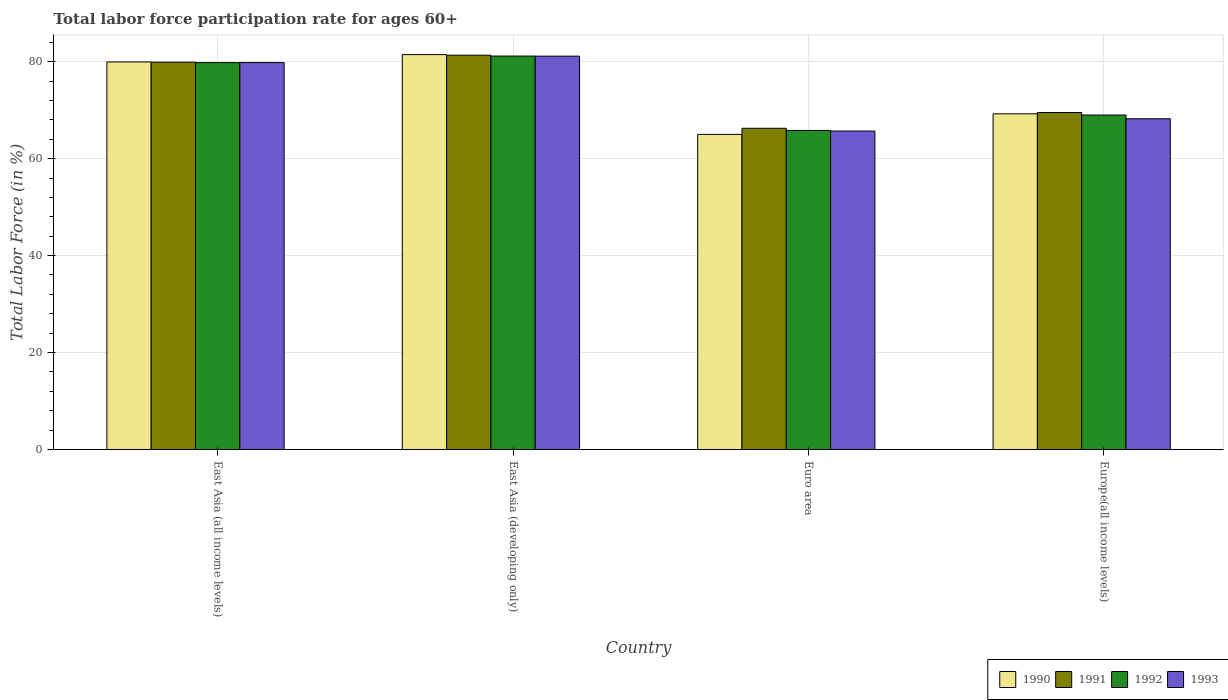How many different coloured bars are there?
Provide a succinct answer. 4. How many groups of bars are there?
Your answer should be very brief. 4. Are the number of bars per tick equal to the number of legend labels?
Your answer should be compact. Yes. Are the number of bars on each tick of the X-axis equal?
Ensure brevity in your answer.  Yes. How many bars are there on the 3rd tick from the left?
Give a very brief answer. 4. How many bars are there on the 4th tick from the right?
Offer a very short reply. 4. What is the label of the 2nd group of bars from the left?
Offer a very short reply. East Asia (developing only). What is the labor force participation rate in 1991 in East Asia (all income levels)?
Your response must be concise. 79.9. Across all countries, what is the maximum labor force participation rate in 1991?
Offer a terse response. 81.33. Across all countries, what is the minimum labor force participation rate in 1993?
Offer a terse response. 65.69. In which country was the labor force participation rate in 1991 maximum?
Keep it short and to the point. East Asia (developing only). In which country was the labor force participation rate in 1991 minimum?
Ensure brevity in your answer.  Euro area. What is the total labor force participation rate in 1990 in the graph?
Your response must be concise. 295.64. What is the difference between the labor force participation rate in 1990 in East Asia (developing only) and that in Europe(all income levels)?
Give a very brief answer. 12.21. What is the difference between the labor force participation rate in 1991 in Euro area and the labor force participation rate in 1990 in Europe(all income levels)?
Provide a short and direct response. -2.99. What is the average labor force participation rate in 1993 per country?
Offer a very short reply. 73.71. What is the difference between the labor force participation rate of/in 1991 and labor force participation rate of/in 1993 in Europe(all income levels)?
Give a very brief answer. 1.29. What is the ratio of the labor force participation rate in 1992 in East Asia (all income levels) to that in Euro area?
Provide a short and direct response. 1.21. What is the difference between the highest and the second highest labor force participation rate in 1990?
Your answer should be compact. 12.21. What is the difference between the highest and the lowest labor force participation rate in 1993?
Ensure brevity in your answer.  15.45. Is the sum of the labor force participation rate in 1990 in East Asia (developing only) and Euro area greater than the maximum labor force participation rate in 1992 across all countries?
Ensure brevity in your answer.  Yes. What does the 2nd bar from the left in Europe(all income levels) represents?
Offer a very short reply. 1991. Are all the bars in the graph horizontal?
Provide a succinct answer. No. How many countries are there in the graph?
Your answer should be compact. 4. What is the difference between two consecutive major ticks on the Y-axis?
Your answer should be very brief. 20. Are the values on the major ticks of Y-axis written in scientific E-notation?
Give a very brief answer. No. Where does the legend appear in the graph?
Give a very brief answer. Bottom right. How many legend labels are there?
Give a very brief answer. 4. What is the title of the graph?
Provide a succinct answer. Total labor force participation rate for ages 60+. Does "1991" appear as one of the legend labels in the graph?
Give a very brief answer. Yes. What is the label or title of the Y-axis?
Give a very brief answer. Total Labor Force (in %). What is the Total Labor Force (in %) in 1990 in East Asia (all income levels)?
Provide a succinct answer. 79.95. What is the Total Labor Force (in %) of 1991 in East Asia (all income levels)?
Your response must be concise. 79.9. What is the Total Labor Force (in %) in 1992 in East Asia (all income levels)?
Give a very brief answer. 79.8. What is the Total Labor Force (in %) of 1993 in East Asia (all income levels)?
Offer a terse response. 79.81. What is the Total Labor Force (in %) of 1990 in East Asia (developing only)?
Ensure brevity in your answer.  81.45. What is the Total Labor Force (in %) of 1991 in East Asia (developing only)?
Your answer should be compact. 81.33. What is the Total Labor Force (in %) of 1992 in East Asia (developing only)?
Your answer should be very brief. 81.16. What is the Total Labor Force (in %) of 1993 in East Asia (developing only)?
Ensure brevity in your answer.  81.14. What is the Total Labor Force (in %) of 1990 in Euro area?
Give a very brief answer. 65. What is the Total Labor Force (in %) of 1991 in Euro area?
Make the answer very short. 66.26. What is the Total Labor Force (in %) in 1992 in Euro area?
Provide a succinct answer. 65.81. What is the Total Labor Force (in %) in 1993 in Euro area?
Give a very brief answer. 65.69. What is the Total Labor Force (in %) in 1990 in Europe(all income levels)?
Your answer should be very brief. 69.24. What is the Total Labor Force (in %) in 1991 in Europe(all income levels)?
Your answer should be compact. 69.51. What is the Total Labor Force (in %) of 1992 in Europe(all income levels)?
Offer a very short reply. 68.99. What is the Total Labor Force (in %) in 1993 in Europe(all income levels)?
Give a very brief answer. 68.22. Across all countries, what is the maximum Total Labor Force (in %) of 1990?
Offer a terse response. 81.45. Across all countries, what is the maximum Total Labor Force (in %) of 1991?
Provide a succinct answer. 81.33. Across all countries, what is the maximum Total Labor Force (in %) of 1992?
Offer a very short reply. 81.16. Across all countries, what is the maximum Total Labor Force (in %) in 1993?
Offer a terse response. 81.14. Across all countries, what is the minimum Total Labor Force (in %) in 1990?
Your answer should be very brief. 65. Across all countries, what is the minimum Total Labor Force (in %) of 1991?
Provide a short and direct response. 66.26. Across all countries, what is the minimum Total Labor Force (in %) in 1992?
Your response must be concise. 65.81. Across all countries, what is the minimum Total Labor Force (in %) in 1993?
Ensure brevity in your answer.  65.69. What is the total Total Labor Force (in %) in 1990 in the graph?
Give a very brief answer. 295.64. What is the total Total Labor Force (in %) in 1991 in the graph?
Your response must be concise. 297. What is the total Total Labor Force (in %) in 1992 in the graph?
Ensure brevity in your answer.  295.76. What is the total Total Labor Force (in %) of 1993 in the graph?
Your answer should be compact. 294.86. What is the difference between the Total Labor Force (in %) of 1990 in East Asia (all income levels) and that in East Asia (developing only)?
Offer a terse response. -1.51. What is the difference between the Total Labor Force (in %) in 1991 in East Asia (all income levels) and that in East Asia (developing only)?
Provide a short and direct response. -1.43. What is the difference between the Total Labor Force (in %) of 1992 in East Asia (all income levels) and that in East Asia (developing only)?
Make the answer very short. -1.36. What is the difference between the Total Labor Force (in %) in 1993 in East Asia (all income levels) and that in East Asia (developing only)?
Provide a short and direct response. -1.33. What is the difference between the Total Labor Force (in %) in 1990 in East Asia (all income levels) and that in Euro area?
Give a very brief answer. 14.95. What is the difference between the Total Labor Force (in %) in 1991 in East Asia (all income levels) and that in Euro area?
Offer a very short reply. 13.64. What is the difference between the Total Labor Force (in %) in 1992 in East Asia (all income levels) and that in Euro area?
Give a very brief answer. 13.99. What is the difference between the Total Labor Force (in %) in 1993 in East Asia (all income levels) and that in Euro area?
Give a very brief answer. 14.12. What is the difference between the Total Labor Force (in %) in 1990 in East Asia (all income levels) and that in Europe(all income levels)?
Ensure brevity in your answer.  10.7. What is the difference between the Total Labor Force (in %) in 1991 in East Asia (all income levels) and that in Europe(all income levels)?
Ensure brevity in your answer.  10.39. What is the difference between the Total Labor Force (in %) in 1992 in East Asia (all income levels) and that in Europe(all income levels)?
Provide a succinct answer. 10.81. What is the difference between the Total Labor Force (in %) in 1993 in East Asia (all income levels) and that in Europe(all income levels)?
Make the answer very short. 11.59. What is the difference between the Total Labor Force (in %) in 1990 in East Asia (developing only) and that in Euro area?
Give a very brief answer. 16.45. What is the difference between the Total Labor Force (in %) in 1991 in East Asia (developing only) and that in Euro area?
Ensure brevity in your answer.  15.07. What is the difference between the Total Labor Force (in %) in 1992 in East Asia (developing only) and that in Euro area?
Keep it short and to the point. 15.34. What is the difference between the Total Labor Force (in %) in 1993 in East Asia (developing only) and that in Euro area?
Make the answer very short. 15.45. What is the difference between the Total Labor Force (in %) of 1990 in East Asia (developing only) and that in Europe(all income levels)?
Your answer should be compact. 12.21. What is the difference between the Total Labor Force (in %) of 1991 in East Asia (developing only) and that in Europe(all income levels)?
Offer a very short reply. 11.82. What is the difference between the Total Labor Force (in %) in 1992 in East Asia (developing only) and that in Europe(all income levels)?
Your response must be concise. 12.17. What is the difference between the Total Labor Force (in %) of 1993 in East Asia (developing only) and that in Europe(all income levels)?
Provide a short and direct response. 12.91. What is the difference between the Total Labor Force (in %) in 1990 in Euro area and that in Europe(all income levels)?
Your response must be concise. -4.24. What is the difference between the Total Labor Force (in %) of 1991 in Euro area and that in Europe(all income levels)?
Provide a succinct answer. -3.25. What is the difference between the Total Labor Force (in %) of 1992 in Euro area and that in Europe(all income levels)?
Offer a terse response. -3.18. What is the difference between the Total Labor Force (in %) of 1993 in Euro area and that in Europe(all income levels)?
Provide a short and direct response. -2.54. What is the difference between the Total Labor Force (in %) of 1990 in East Asia (all income levels) and the Total Labor Force (in %) of 1991 in East Asia (developing only)?
Your answer should be very brief. -1.39. What is the difference between the Total Labor Force (in %) in 1990 in East Asia (all income levels) and the Total Labor Force (in %) in 1992 in East Asia (developing only)?
Make the answer very short. -1.21. What is the difference between the Total Labor Force (in %) in 1990 in East Asia (all income levels) and the Total Labor Force (in %) in 1993 in East Asia (developing only)?
Your answer should be compact. -1.19. What is the difference between the Total Labor Force (in %) in 1991 in East Asia (all income levels) and the Total Labor Force (in %) in 1992 in East Asia (developing only)?
Make the answer very short. -1.26. What is the difference between the Total Labor Force (in %) in 1991 in East Asia (all income levels) and the Total Labor Force (in %) in 1993 in East Asia (developing only)?
Offer a very short reply. -1.24. What is the difference between the Total Labor Force (in %) of 1992 in East Asia (all income levels) and the Total Labor Force (in %) of 1993 in East Asia (developing only)?
Your answer should be very brief. -1.34. What is the difference between the Total Labor Force (in %) of 1990 in East Asia (all income levels) and the Total Labor Force (in %) of 1991 in Euro area?
Ensure brevity in your answer.  13.69. What is the difference between the Total Labor Force (in %) of 1990 in East Asia (all income levels) and the Total Labor Force (in %) of 1992 in Euro area?
Provide a short and direct response. 14.13. What is the difference between the Total Labor Force (in %) of 1990 in East Asia (all income levels) and the Total Labor Force (in %) of 1993 in Euro area?
Your answer should be compact. 14.26. What is the difference between the Total Labor Force (in %) of 1991 in East Asia (all income levels) and the Total Labor Force (in %) of 1992 in Euro area?
Your response must be concise. 14.09. What is the difference between the Total Labor Force (in %) in 1991 in East Asia (all income levels) and the Total Labor Force (in %) in 1993 in Euro area?
Offer a terse response. 14.22. What is the difference between the Total Labor Force (in %) of 1992 in East Asia (all income levels) and the Total Labor Force (in %) of 1993 in Euro area?
Ensure brevity in your answer.  14.12. What is the difference between the Total Labor Force (in %) in 1990 in East Asia (all income levels) and the Total Labor Force (in %) in 1991 in Europe(all income levels)?
Provide a short and direct response. 10.43. What is the difference between the Total Labor Force (in %) in 1990 in East Asia (all income levels) and the Total Labor Force (in %) in 1992 in Europe(all income levels)?
Your answer should be very brief. 10.95. What is the difference between the Total Labor Force (in %) of 1990 in East Asia (all income levels) and the Total Labor Force (in %) of 1993 in Europe(all income levels)?
Offer a terse response. 11.72. What is the difference between the Total Labor Force (in %) in 1991 in East Asia (all income levels) and the Total Labor Force (in %) in 1992 in Europe(all income levels)?
Give a very brief answer. 10.91. What is the difference between the Total Labor Force (in %) in 1991 in East Asia (all income levels) and the Total Labor Force (in %) in 1993 in Europe(all income levels)?
Keep it short and to the point. 11.68. What is the difference between the Total Labor Force (in %) of 1992 in East Asia (all income levels) and the Total Labor Force (in %) of 1993 in Europe(all income levels)?
Your answer should be very brief. 11.58. What is the difference between the Total Labor Force (in %) of 1990 in East Asia (developing only) and the Total Labor Force (in %) of 1991 in Euro area?
Your response must be concise. 15.19. What is the difference between the Total Labor Force (in %) in 1990 in East Asia (developing only) and the Total Labor Force (in %) in 1992 in Euro area?
Give a very brief answer. 15.64. What is the difference between the Total Labor Force (in %) of 1990 in East Asia (developing only) and the Total Labor Force (in %) of 1993 in Euro area?
Provide a succinct answer. 15.77. What is the difference between the Total Labor Force (in %) in 1991 in East Asia (developing only) and the Total Labor Force (in %) in 1992 in Euro area?
Make the answer very short. 15.52. What is the difference between the Total Labor Force (in %) of 1991 in East Asia (developing only) and the Total Labor Force (in %) of 1993 in Euro area?
Your answer should be very brief. 15.65. What is the difference between the Total Labor Force (in %) in 1992 in East Asia (developing only) and the Total Labor Force (in %) in 1993 in Euro area?
Your answer should be very brief. 15.47. What is the difference between the Total Labor Force (in %) in 1990 in East Asia (developing only) and the Total Labor Force (in %) in 1991 in Europe(all income levels)?
Give a very brief answer. 11.94. What is the difference between the Total Labor Force (in %) in 1990 in East Asia (developing only) and the Total Labor Force (in %) in 1992 in Europe(all income levels)?
Keep it short and to the point. 12.46. What is the difference between the Total Labor Force (in %) of 1990 in East Asia (developing only) and the Total Labor Force (in %) of 1993 in Europe(all income levels)?
Keep it short and to the point. 13.23. What is the difference between the Total Labor Force (in %) in 1991 in East Asia (developing only) and the Total Labor Force (in %) in 1992 in Europe(all income levels)?
Your response must be concise. 12.34. What is the difference between the Total Labor Force (in %) of 1991 in East Asia (developing only) and the Total Labor Force (in %) of 1993 in Europe(all income levels)?
Give a very brief answer. 13.11. What is the difference between the Total Labor Force (in %) in 1992 in East Asia (developing only) and the Total Labor Force (in %) in 1993 in Europe(all income levels)?
Provide a short and direct response. 12.93. What is the difference between the Total Labor Force (in %) in 1990 in Euro area and the Total Labor Force (in %) in 1991 in Europe(all income levels)?
Give a very brief answer. -4.51. What is the difference between the Total Labor Force (in %) of 1990 in Euro area and the Total Labor Force (in %) of 1992 in Europe(all income levels)?
Ensure brevity in your answer.  -3.99. What is the difference between the Total Labor Force (in %) of 1990 in Euro area and the Total Labor Force (in %) of 1993 in Europe(all income levels)?
Offer a terse response. -3.22. What is the difference between the Total Labor Force (in %) in 1991 in Euro area and the Total Labor Force (in %) in 1992 in Europe(all income levels)?
Give a very brief answer. -2.73. What is the difference between the Total Labor Force (in %) of 1991 in Euro area and the Total Labor Force (in %) of 1993 in Europe(all income levels)?
Offer a terse response. -1.97. What is the difference between the Total Labor Force (in %) in 1992 in Euro area and the Total Labor Force (in %) in 1993 in Europe(all income levels)?
Your response must be concise. -2.41. What is the average Total Labor Force (in %) in 1990 per country?
Your response must be concise. 73.91. What is the average Total Labor Force (in %) of 1991 per country?
Your answer should be very brief. 74.25. What is the average Total Labor Force (in %) of 1992 per country?
Offer a terse response. 73.94. What is the average Total Labor Force (in %) of 1993 per country?
Offer a very short reply. 73.71. What is the difference between the Total Labor Force (in %) in 1990 and Total Labor Force (in %) in 1991 in East Asia (all income levels)?
Your answer should be very brief. 0.04. What is the difference between the Total Labor Force (in %) of 1990 and Total Labor Force (in %) of 1992 in East Asia (all income levels)?
Your response must be concise. 0.14. What is the difference between the Total Labor Force (in %) in 1990 and Total Labor Force (in %) in 1993 in East Asia (all income levels)?
Provide a succinct answer. 0.14. What is the difference between the Total Labor Force (in %) in 1991 and Total Labor Force (in %) in 1992 in East Asia (all income levels)?
Keep it short and to the point. 0.1. What is the difference between the Total Labor Force (in %) in 1991 and Total Labor Force (in %) in 1993 in East Asia (all income levels)?
Offer a terse response. 0.09. What is the difference between the Total Labor Force (in %) of 1992 and Total Labor Force (in %) of 1993 in East Asia (all income levels)?
Your answer should be very brief. -0.01. What is the difference between the Total Labor Force (in %) of 1990 and Total Labor Force (in %) of 1991 in East Asia (developing only)?
Offer a terse response. 0.12. What is the difference between the Total Labor Force (in %) of 1990 and Total Labor Force (in %) of 1992 in East Asia (developing only)?
Provide a short and direct response. 0.3. What is the difference between the Total Labor Force (in %) of 1990 and Total Labor Force (in %) of 1993 in East Asia (developing only)?
Make the answer very short. 0.32. What is the difference between the Total Labor Force (in %) in 1991 and Total Labor Force (in %) in 1992 in East Asia (developing only)?
Make the answer very short. 0.17. What is the difference between the Total Labor Force (in %) in 1991 and Total Labor Force (in %) in 1993 in East Asia (developing only)?
Offer a terse response. 0.19. What is the difference between the Total Labor Force (in %) in 1992 and Total Labor Force (in %) in 1993 in East Asia (developing only)?
Offer a very short reply. 0.02. What is the difference between the Total Labor Force (in %) of 1990 and Total Labor Force (in %) of 1991 in Euro area?
Keep it short and to the point. -1.26. What is the difference between the Total Labor Force (in %) in 1990 and Total Labor Force (in %) in 1992 in Euro area?
Keep it short and to the point. -0.81. What is the difference between the Total Labor Force (in %) of 1990 and Total Labor Force (in %) of 1993 in Euro area?
Ensure brevity in your answer.  -0.69. What is the difference between the Total Labor Force (in %) in 1991 and Total Labor Force (in %) in 1992 in Euro area?
Your answer should be very brief. 0.45. What is the difference between the Total Labor Force (in %) of 1991 and Total Labor Force (in %) of 1993 in Euro area?
Offer a very short reply. 0.57. What is the difference between the Total Labor Force (in %) in 1992 and Total Labor Force (in %) in 1993 in Euro area?
Your response must be concise. 0.13. What is the difference between the Total Labor Force (in %) of 1990 and Total Labor Force (in %) of 1991 in Europe(all income levels)?
Offer a terse response. -0.27. What is the difference between the Total Labor Force (in %) in 1990 and Total Labor Force (in %) in 1992 in Europe(all income levels)?
Provide a succinct answer. 0.25. What is the difference between the Total Labor Force (in %) of 1990 and Total Labor Force (in %) of 1993 in Europe(all income levels)?
Your response must be concise. 1.02. What is the difference between the Total Labor Force (in %) in 1991 and Total Labor Force (in %) in 1992 in Europe(all income levels)?
Your answer should be compact. 0.52. What is the difference between the Total Labor Force (in %) in 1991 and Total Labor Force (in %) in 1993 in Europe(all income levels)?
Provide a succinct answer. 1.29. What is the difference between the Total Labor Force (in %) in 1992 and Total Labor Force (in %) in 1993 in Europe(all income levels)?
Your response must be concise. 0.77. What is the ratio of the Total Labor Force (in %) of 1990 in East Asia (all income levels) to that in East Asia (developing only)?
Offer a very short reply. 0.98. What is the ratio of the Total Labor Force (in %) in 1991 in East Asia (all income levels) to that in East Asia (developing only)?
Provide a succinct answer. 0.98. What is the ratio of the Total Labor Force (in %) in 1992 in East Asia (all income levels) to that in East Asia (developing only)?
Offer a terse response. 0.98. What is the ratio of the Total Labor Force (in %) of 1993 in East Asia (all income levels) to that in East Asia (developing only)?
Provide a short and direct response. 0.98. What is the ratio of the Total Labor Force (in %) of 1990 in East Asia (all income levels) to that in Euro area?
Ensure brevity in your answer.  1.23. What is the ratio of the Total Labor Force (in %) of 1991 in East Asia (all income levels) to that in Euro area?
Your answer should be very brief. 1.21. What is the ratio of the Total Labor Force (in %) of 1992 in East Asia (all income levels) to that in Euro area?
Give a very brief answer. 1.21. What is the ratio of the Total Labor Force (in %) in 1993 in East Asia (all income levels) to that in Euro area?
Make the answer very short. 1.22. What is the ratio of the Total Labor Force (in %) of 1990 in East Asia (all income levels) to that in Europe(all income levels)?
Ensure brevity in your answer.  1.15. What is the ratio of the Total Labor Force (in %) in 1991 in East Asia (all income levels) to that in Europe(all income levels)?
Your answer should be compact. 1.15. What is the ratio of the Total Labor Force (in %) of 1992 in East Asia (all income levels) to that in Europe(all income levels)?
Your response must be concise. 1.16. What is the ratio of the Total Labor Force (in %) in 1993 in East Asia (all income levels) to that in Europe(all income levels)?
Make the answer very short. 1.17. What is the ratio of the Total Labor Force (in %) of 1990 in East Asia (developing only) to that in Euro area?
Keep it short and to the point. 1.25. What is the ratio of the Total Labor Force (in %) of 1991 in East Asia (developing only) to that in Euro area?
Make the answer very short. 1.23. What is the ratio of the Total Labor Force (in %) in 1992 in East Asia (developing only) to that in Euro area?
Provide a short and direct response. 1.23. What is the ratio of the Total Labor Force (in %) in 1993 in East Asia (developing only) to that in Euro area?
Provide a succinct answer. 1.24. What is the ratio of the Total Labor Force (in %) of 1990 in East Asia (developing only) to that in Europe(all income levels)?
Provide a succinct answer. 1.18. What is the ratio of the Total Labor Force (in %) of 1991 in East Asia (developing only) to that in Europe(all income levels)?
Your response must be concise. 1.17. What is the ratio of the Total Labor Force (in %) of 1992 in East Asia (developing only) to that in Europe(all income levels)?
Ensure brevity in your answer.  1.18. What is the ratio of the Total Labor Force (in %) of 1993 in East Asia (developing only) to that in Europe(all income levels)?
Provide a short and direct response. 1.19. What is the ratio of the Total Labor Force (in %) of 1990 in Euro area to that in Europe(all income levels)?
Your answer should be compact. 0.94. What is the ratio of the Total Labor Force (in %) of 1991 in Euro area to that in Europe(all income levels)?
Keep it short and to the point. 0.95. What is the ratio of the Total Labor Force (in %) in 1992 in Euro area to that in Europe(all income levels)?
Offer a terse response. 0.95. What is the ratio of the Total Labor Force (in %) of 1993 in Euro area to that in Europe(all income levels)?
Offer a terse response. 0.96. What is the difference between the highest and the second highest Total Labor Force (in %) of 1990?
Ensure brevity in your answer.  1.51. What is the difference between the highest and the second highest Total Labor Force (in %) of 1991?
Offer a very short reply. 1.43. What is the difference between the highest and the second highest Total Labor Force (in %) in 1992?
Ensure brevity in your answer.  1.36. What is the difference between the highest and the second highest Total Labor Force (in %) in 1993?
Keep it short and to the point. 1.33. What is the difference between the highest and the lowest Total Labor Force (in %) in 1990?
Ensure brevity in your answer.  16.45. What is the difference between the highest and the lowest Total Labor Force (in %) of 1991?
Provide a short and direct response. 15.07. What is the difference between the highest and the lowest Total Labor Force (in %) in 1992?
Your answer should be compact. 15.34. What is the difference between the highest and the lowest Total Labor Force (in %) in 1993?
Keep it short and to the point. 15.45. 